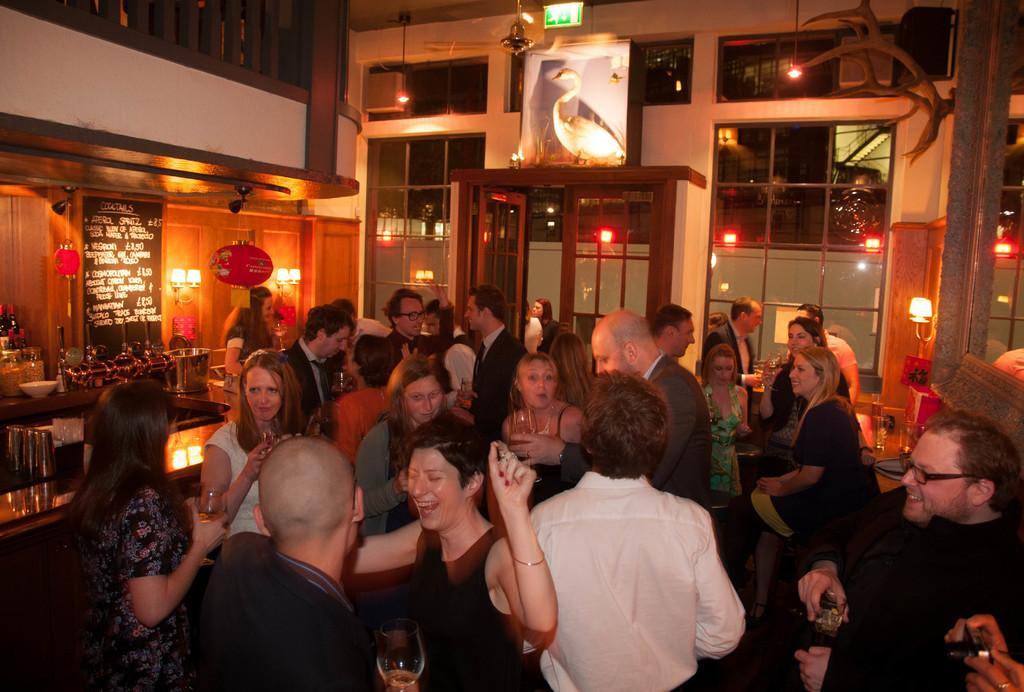In one or two sentences, can you explain what this image depicts? In this picture there are group of people standing and holding the glasses. On the left side of the image there are bottles, glasses, jars and there is a bowl on the table and there are lights on the wall. On the right side of the image there are glasses on the table. At the back there is a door. At the top there is a picture of a bird. There are two persons standing behind the door. 